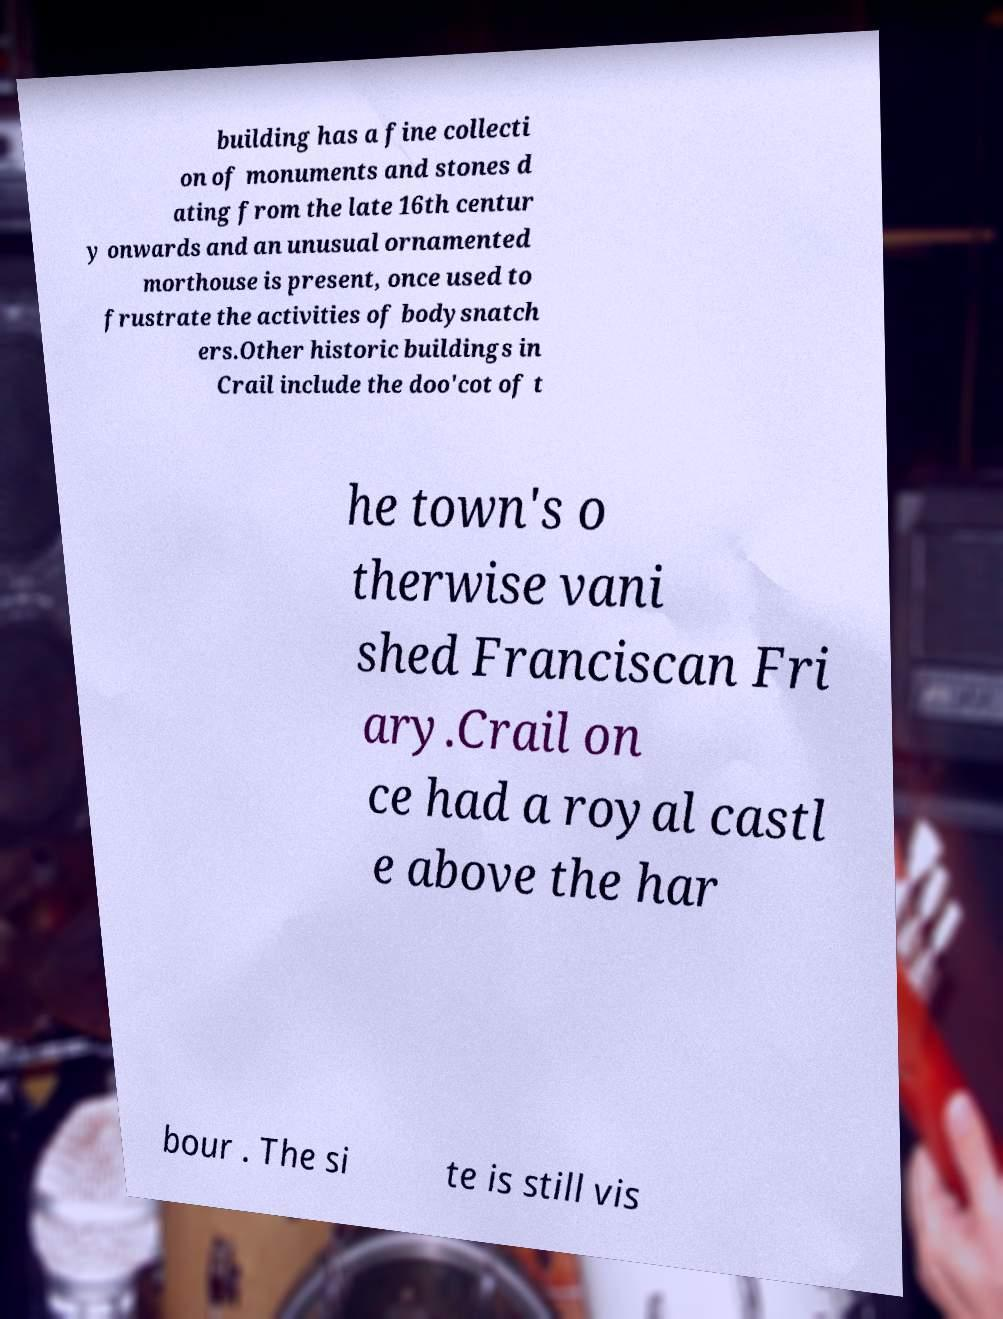Please identify and transcribe the text found in this image. building has a fine collecti on of monuments and stones d ating from the late 16th centur y onwards and an unusual ornamented morthouse is present, once used to frustrate the activities of bodysnatch ers.Other historic buildings in Crail include the doo'cot of t he town's o therwise vani shed Franciscan Fri ary.Crail on ce had a royal castl e above the har bour . The si te is still vis 